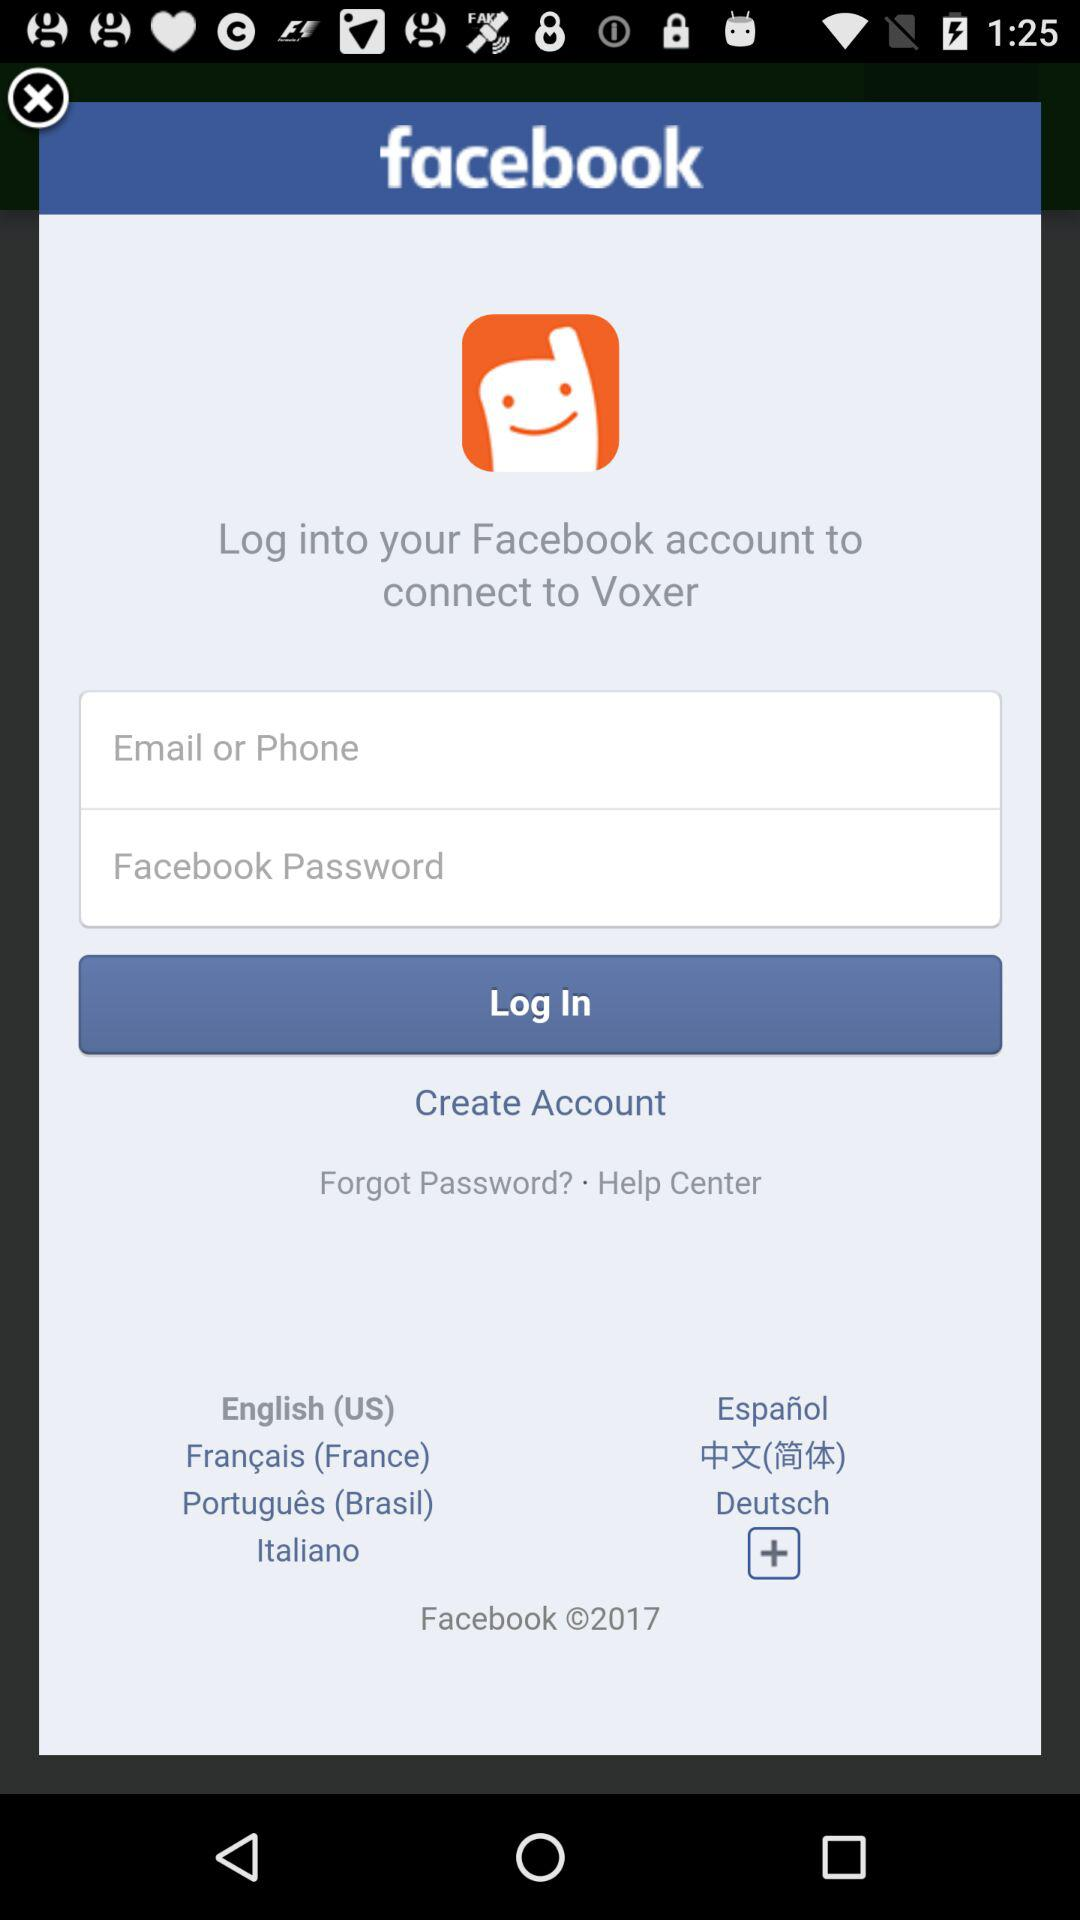What are the application names? The application names are "Facebook" and "Voxer". 